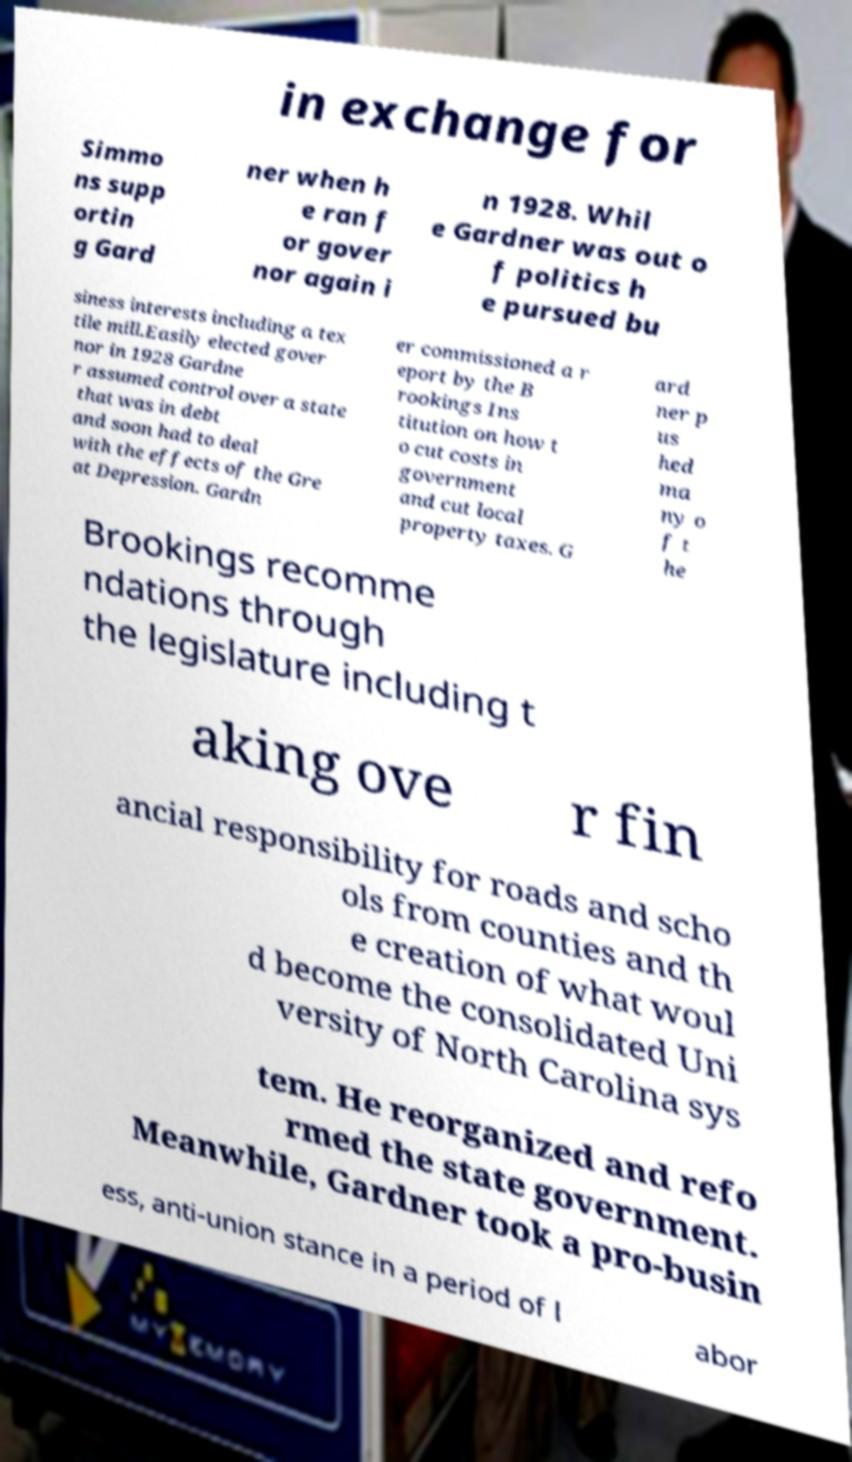I need the written content from this picture converted into text. Can you do that? in exchange for Simmo ns supp ortin g Gard ner when h e ran f or gover nor again i n 1928. Whil e Gardner was out o f politics h e pursued bu siness interests including a tex tile mill.Easily elected gover nor in 1928 Gardne r assumed control over a state that was in debt and soon had to deal with the effects of the Gre at Depression. Gardn er commissioned a r eport by the B rookings Ins titution on how t o cut costs in government and cut local property taxes. G ard ner p us hed ma ny o f t he Brookings recomme ndations through the legislature including t aking ove r fin ancial responsibility for roads and scho ols from counties and th e creation of what woul d become the consolidated Uni versity of North Carolina sys tem. He reorganized and refo rmed the state government. Meanwhile, Gardner took a pro-busin ess, anti-union stance in a period of l abor 